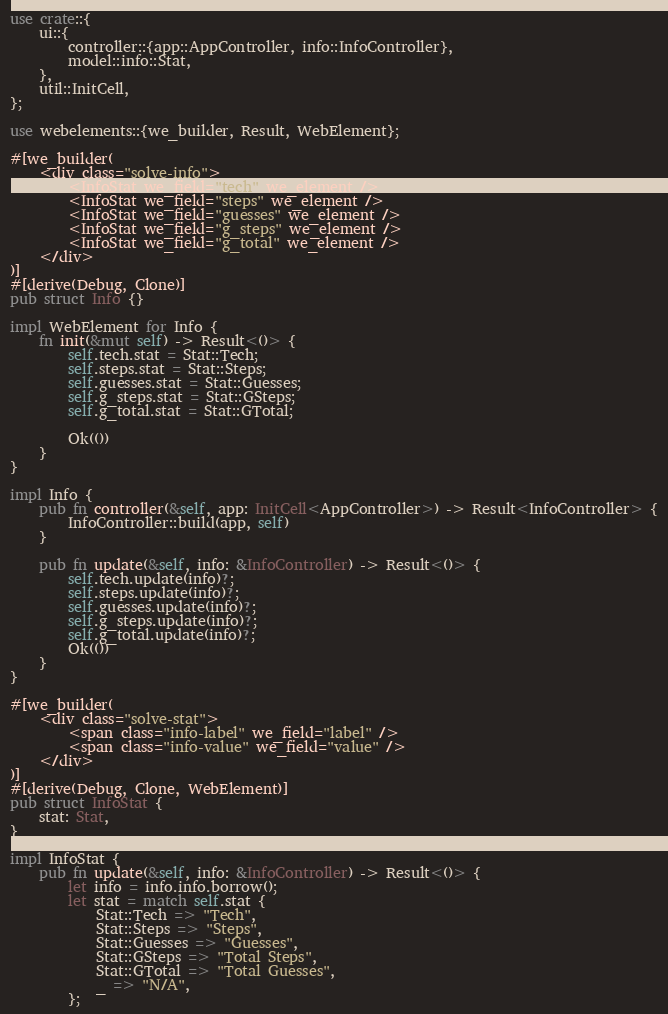<code> <loc_0><loc_0><loc_500><loc_500><_Rust_>use crate::{
    ui::{
        controller::{app::AppController, info::InfoController},
        model::info::Stat,
    },
    util::InitCell,
};

use webelements::{we_builder, Result, WebElement};

#[we_builder(
    <div class="solve-info">
        <InfoStat we_field="tech" we_element />
        <InfoStat we_field="steps" we_element />
        <InfoStat we_field="guesses" we_element />
        <InfoStat we_field="g_steps" we_element />
        <InfoStat we_field="g_total" we_element />
    </div>
)]
#[derive(Debug, Clone)]
pub struct Info {}

impl WebElement for Info {
    fn init(&mut self) -> Result<()> {
        self.tech.stat = Stat::Tech;
        self.steps.stat = Stat::Steps;
        self.guesses.stat = Stat::Guesses;
        self.g_steps.stat = Stat::GSteps;
        self.g_total.stat = Stat::GTotal;

        Ok(())
    }
}

impl Info {
    pub fn controller(&self, app: InitCell<AppController>) -> Result<InfoController> {
        InfoController::build(app, self)
    }

    pub fn update(&self, info: &InfoController) -> Result<()> {
        self.tech.update(info)?;
        self.steps.update(info)?;
        self.guesses.update(info)?;
        self.g_steps.update(info)?;
        self.g_total.update(info)?;
        Ok(())
    }
}

#[we_builder(
    <div class="solve-stat">
        <span class="info-label" we_field="label" />
        <span class="info-value" we_field="value" />
    </div>
)]
#[derive(Debug, Clone, WebElement)]
pub struct InfoStat {
    stat: Stat,
}

impl InfoStat {
    pub fn update(&self, info: &InfoController) -> Result<()> {
        let info = info.info.borrow();
        let stat = match self.stat {
            Stat::Tech => "Tech",
            Stat::Steps => "Steps",
            Stat::Guesses => "Guesses",
            Stat::GSteps => "Total Steps",
            Stat::GTotal => "Total Guesses",
            _ => "N/A",
        };</code> 